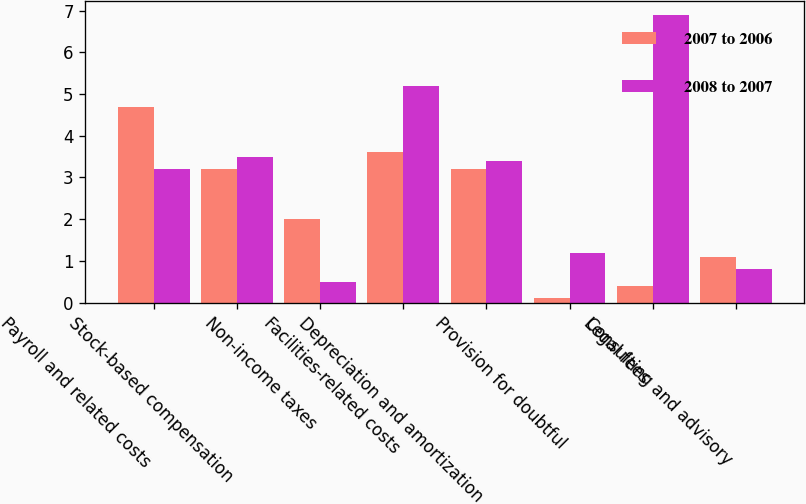Convert chart to OTSL. <chart><loc_0><loc_0><loc_500><loc_500><stacked_bar_chart><ecel><fcel>Payroll and related costs<fcel>Stock-based compensation<fcel>Non-income taxes<fcel>Facilities-related costs<fcel>Depreciation and amortization<fcel>Provision for doubtful<fcel>Legal fees<fcel>Consulting and advisory<nl><fcel>2007 to 2006<fcel>4.7<fcel>3.2<fcel>2<fcel>3.6<fcel>3.2<fcel>0.1<fcel>0.4<fcel>1.1<nl><fcel>2008 to 2007<fcel>3.2<fcel>3.5<fcel>0.5<fcel>5.2<fcel>3.4<fcel>1.2<fcel>6.9<fcel>0.8<nl></chart> 